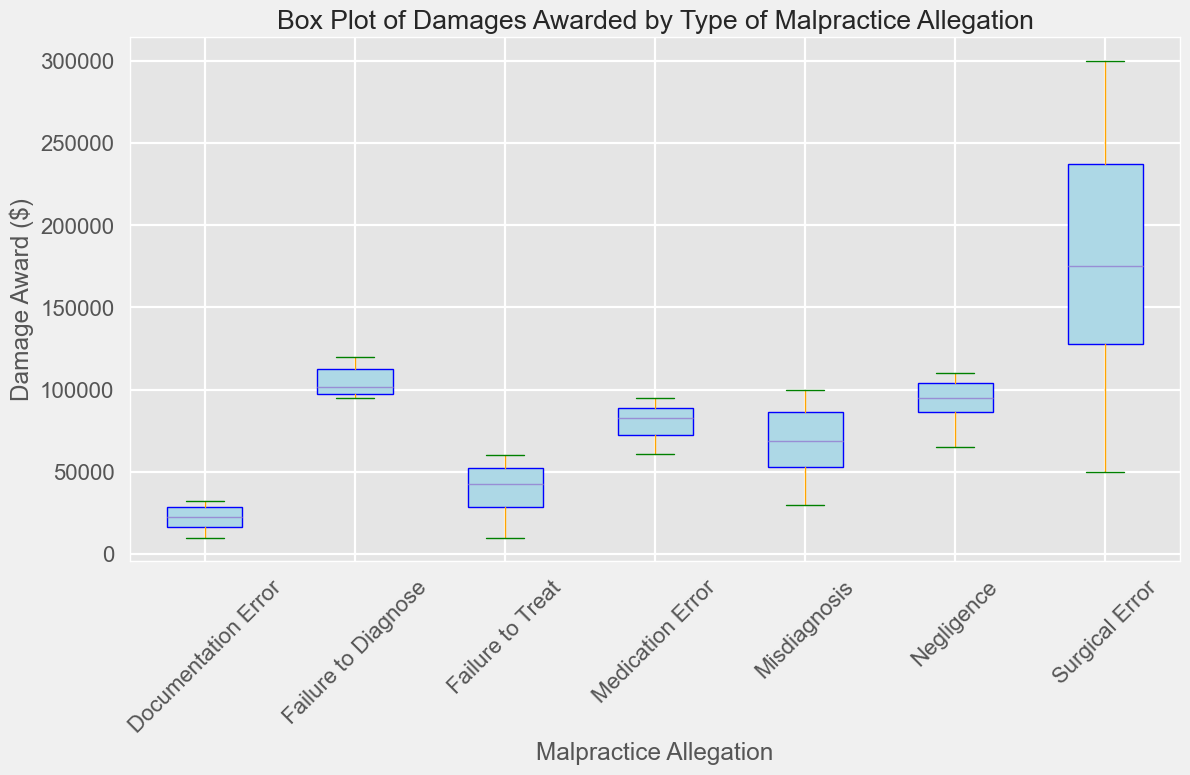Which category of malpractice allegation has the highest median damage award? To find the category with the highest median damage award, look for the box plots' horizontal lines in the middle, which represent the medians. Identify the median with the highest value.
Answer: Surgical Error Which malpractice allegation category shows the largest interquartile range (IQR)? The IQR is the range between the 25th percentile (bottom of the box) and the 75th percentile (top of the box). Look for the box plot with the largest vertical height.
Answer: Surgical Error How does the median damage award for 'Misdiagnosis' compare to the median for 'Failure to Treat'? Identify the median lines (middle lines) in both box plots and compare their vertical positions.
Answer: The median for Misdiagnosis is higher than for Failure to Treat What is the range of damage awards for 'Documentation Error'? The range is the difference between the maximum (top whisker) and minimum (bottom whisker) values. Identify these points on the box plot for Documentation Error.
Answer: $32000 - $10000 Which malpractice allegation has the smallest maximum damage award? Look at the top whisker of each box plot and find the one that reaches the lowest value.
Answer: Documentation Error Are there any outliers in the 'Negligence' category? Check for any points that fall outside the whiskers of the box plot for Negligence. These points are typically marked with circles or dots.
Answer: No How do the median damage awards for 'Medication Error' and 'Failure to Diagnose' compare? Compare the median lines (horizontal lines in the middle of each box) for Medication Error and Failure to Diagnose.
Answer: The median for Failure to Diagnose is higher Approximately, what's the overall shape and distribution (spread) of damage awards for 'Surgical Error'? Look at the spread (IQR), range (whiskers), and presence of outliers to describe the distribution's characteristics for Surgical Error.
Answer: Higher median, wide spread, and higher maximum values Which category appears to have the most consistent (least variable) damage awards? Look for the box plot with the smallest IQR (shortest box height) and the shortest range between whiskers.
Answer: Documentation Error 